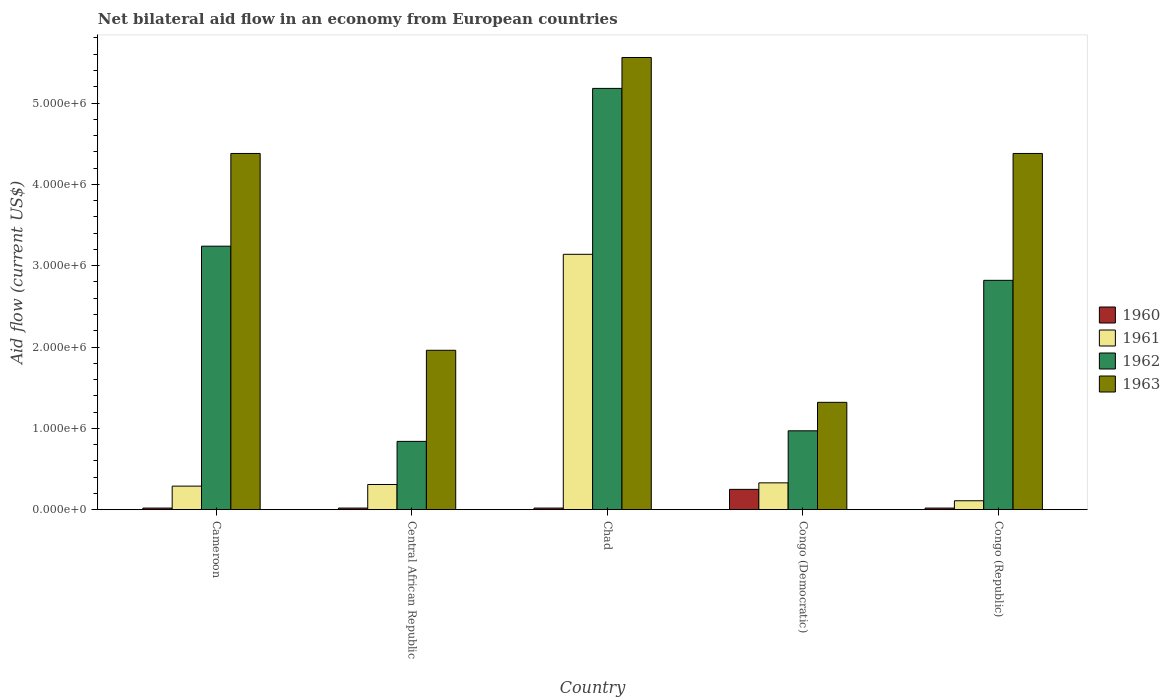How many different coloured bars are there?
Keep it short and to the point. 4. Are the number of bars per tick equal to the number of legend labels?
Your answer should be compact. Yes. Are the number of bars on each tick of the X-axis equal?
Provide a succinct answer. Yes. How many bars are there on the 4th tick from the right?
Ensure brevity in your answer.  4. What is the label of the 2nd group of bars from the left?
Keep it short and to the point. Central African Republic. What is the net bilateral aid flow in 1960 in Central African Republic?
Your response must be concise. 2.00e+04. Across all countries, what is the maximum net bilateral aid flow in 1960?
Provide a succinct answer. 2.50e+05. Across all countries, what is the minimum net bilateral aid flow in 1961?
Ensure brevity in your answer.  1.10e+05. In which country was the net bilateral aid flow in 1962 maximum?
Your response must be concise. Chad. In which country was the net bilateral aid flow in 1963 minimum?
Provide a short and direct response. Congo (Democratic). What is the total net bilateral aid flow in 1961 in the graph?
Give a very brief answer. 4.18e+06. What is the difference between the net bilateral aid flow in 1963 in Congo (Democratic) and that in Congo (Republic)?
Provide a short and direct response. -3.06e+06. What is the difference between the net bilateral aid flow in 1962 in Congo (Republic) and the net bilateral aid flow in 1961 in Congo (Democratic)?
Your answer should be very brief. 2.49e+06. What is the average net bilateral aid flow in 1960 per country?
Make the answer very short. 6.60e+04. What is the difference between the net bilateral aid flow of/in 1963 and net bilateral aid flow of/in 1960 in Chad?
Make the answer very short. 5.54e+06. In how many countries, is the net bilateral aid flow in 1960 greater than 1400000 US$?
Your answer should be very brief. 0. What is the ratio of the net bilateral aid flow in 1963 in Central African Republic to that in Congo (Republic)?
Keep it short and to the point. 0.45. Is the net bilateral aid flow in 1960 in Central African Republic less than that in Congo (Democratic)?
Offer a very short reply. Yes. Is the difference between the net bilateral aid flow in 1963 in Congo (Democratic) and Congo (Republic) greater than the difference between the net bilateral aid flow in 1960 in Congo (Democratic) and Congo (Republic)?
Provide a succinct answer. No. What is the difference between the highest and the second highest net bilateral aid flow in 1963?
Provide a short and direct response. 1.18e+06. In how many countries, is the net bilateral aid flow in 1960 greater than the average net bilateral aid flow in 1960 taken over all countries?
Your answer should be very brief. 1. Is the sum of the net bilateral aid flow in 1960 in Central African Republic and Congo (Democratic) greater than the maximum net bilateral aid flow in 1961 across all countries?
Your response must be concise. No. Is it the case that in every country, the sum of the net bilateral aid flow in 1963 and net bilateral aid flow in 1962 is greater than the sum of net bilateral aid flow in 1961 and net bilateral aid flow in 1960?
Keep it short and to the point. Yes. What does the 4th bar from the right in Central African Republic represents?
Offer a terse response. 1960. How many bars are there?
Provide a succinct answer. 20. How many countries are there in the graph?
Your answer should be compact. 5. What is the difference between two consecutive major ticks on the Y-axis?
Give a very brief answer. 1.00e+06. Are the values on the major ticks of Y-axis written in scientific E-notation?
Make the answer very short. Yes. Does the graph contain grids?
Keep it short and to the point. No. Where does the legend appear in the graph?
Your answer should be compact. Center right. How are the legend labels stacked?
Give a very brief answer. Vertical. What is the title of the graph?
Your answer should be very brief. Net bilateral aid flow in an economy from European countries. What is the Aid flow (current US$) in 1961 in Cameroon?
Your answer should be compact. 2.90e+05. What is the Aid flow (current US$) in 1962 in Cameroon?
Your answer should be very brief. 3.24e+06. What is the Aid flow (current US$) of 1963 in Cameroon?
Provide a short and direct response. 4.38e+06. What is the Aid flow (current US$) of 1962 in Central African Republic?
Provide a short and direct response. 8.40e+05. What is the Aid flow (current US$) in 1963 in Central African Republic?
Make the answer very short. 1.96e+06. What is the Aid flow (current US$) in 1961 in Chad?
Give a very brief answer. 3.14e+06. What is the Aid flow (current US$) in 1962 in Chad?
Provide a succinct answer. 5.18e+06. What is the Aid flow (current US$) in 1963 in Chad?
Offer a very short reply. 5.56e+06. What is the Aid flow (current US$) of 1961 in Congo (Democratic)?
Give a very brief answer. 3.30e+05. What is the Aid flow (current US$) of 1962 in Congo (Democratic)?
Offer a very short reply. 9.70e+05. What is the Aid flow (current US$) of 1963 in Congo (Democratic)?
Give a very brief answer. 1.32e+06. What is the Aid flow (current US$) of 1960 in Congo (Republic)?
Keep it short and to the point. 2.00e+04. What is the Aid flow (current US$) in 1962 in Congo (Republic)?
Give a very brief answer. 2.82e+06. What is the Aid flow (current US$) of 1963 in Congo (Republic)?
Your answer should be compact. 4.38e+06. Across all countries, what is the maximum Aid flow (current US$) in 1960?
Your response must be concise. 2.50e+05. Across all countries, what is the maximum Aid flow (current US$) of 1961?
Ensure brevity in your answer.  3.14e+06. Across all countries, what is the maximum Aid flow (current US$) in 1962?
Your answer should be compact. 5.18e+06. Across all countries, what is the maximum Aid flow (current US$) in 1963?
Offer a very short reply. 5.56e+06. Across all countries, what is the minimum Aid flow (current US$) in 1960?
Offer a very short reply. 2.00e+04. Across all countries, what is the minimum Aid flow (current US$) of 1961?
Provide a short and direct response. 1.10e+05. Across all countries, what is the minimum Aid flow (current US$) of 1962?
Your answer should be very brief. 8.40e+05. Across all countries, what is the minimum Aid flow (current US$) of 1963?
Give a very brief answer. 1.32e+06. What is the total Aid flow (current US$) in 1961 in the graph?
Keep it short and to the point. 4.18e+06. What is the total Aid flow (current US$) of 1962 in the graph?
Make the answer very short. 1.30e+07. What is the total Aid flow (current US$) in 1963 in the graph?
Keep it short and to the point. 1.76e+07. What is the difference between the Aid flow (current US$) in 1962 in Cameroon and that in Central African Republic?
Provide a short and direct response. 2.40e+06. What is the difference between the Aid flow (current US$) of 1963 in Cameroon and that in Central African Republic?
Your answer should be very brief. 2.42e+06. What is the difference between the Aid flow (current US$) in 1961 in Cameroon and that in Chad?
Ensure brevity in your answer.  -2.85e+06. What is the difference between the Aid flow (current US$) in 1962 in Cameroon and that in Chad?
Your answer should be compact. -1.94e+06. What is the difference between the Aid flow (current US$) of 1963 in Cameroon and that in Chad?
Make the answer very short. -1.18e+06. What is the difference between the Aid flow (current US$) of 1961 in Cameroon and that in Congo (Democratic)?
Provide a succinct answer. -4.00e+04. What is the difference between the Aid flow (current US$) of 1962 in Cameroon and that in Congo (Democratic)?
Offer a very short reply. 2.27e+06. What is the difference between the Aid flow (current US$) in 1963 in Cameroon and that in Congo (Democratic)?
Ensure brevity in your answer.  3.06e+06. What is the difference between the Aid flow (current US$) in 1961 in Cameroon and that in Congo (Republic)?
Offer a terse response. 1.80e+05. What is the difference between the Aid flow (current US$) in 1962 in Cameroon and that in Congo (Republic)?
Make the answer very short. 4.20e+05. What is the difference between the Aid flow (current US$) in 1961 in Central African Republic and that in Chad?
Keep it short and to the point. -2.83e+06. What is the difference between the Aid flow (current US$) of 1962 in Central African Republic and that in Chad?
Your answer should be compact. -4.34e+06. What is the difference between the Aid flow (current US$) in 1963 in Central African Republic and that in Chad?
Your answer should be very brief. -3.60e+06. What is the difference between the Aid flow (current US$) in 1961 in Central African Republic and that in Congo (Democratic)?
Offer a very short reply. -2.00e+04. What is the difference between the Aid flow (current US$) in 1963 in Central African Republic and that in Congo (Democratic)?
Give a very brief answer. 6.40e+05. What is the difference between the Aid flow (current US$) of 1961 in Central African Republic and that in Congo (Republic)?
Provide a succinct answer. 2.00e+05. What is the difference between the Aid flow (current US$) in 1962 in Central African Republic and that in Congo (Republic)?
Offer a terse response. -1.98e+06. What is the difference between the Aid flow (current US$) in 1963 in Central African Republic and that in Congo (Republic)?
Offer a terse response. -2.42e+06. What is the difference between the Aid flow (current US$) in 1960 in Chad and that in Congo (Democratic)?
Your response must be concise. -2.30e+05. What is the difference between the Aid flow (current US$) of 1961 in Chad and that in Congo (Democratic)?
Make the answer very short. 2.81e+06. What is the difference between the Aid flow (current US$) of 1962 in Chad and that in Congo (Democratic)?
Your answer should be compact. 4.21e+06. What is the difference between the Aid flow (current US$) of 1963 in Chad and that in Congo (Democratic)?
Offer a terse response. 4.24e+06. What is the difference between the Aid flow (current US$) of 1960 in Chad and that in Congo (Republic)?
Keep it short and to the point. 0. What is the difference between the Aid flow (current US$) in 1961 in Chad and that in Congo (Republic)?
Your answer should be very brief. 3.03e+06. What is the difference between the Aid flow (current US$) of 1962 in Chad and that in Congo (Republic)?
Your answer should be very brief. 2.36e+06. What is the difference between the Aid flow (current US$) in 1963 in Chad and that in Congo (Republic)?
Provide a short and direct response. 1.18e+06. What is the difference between the Aid flow (current US$) of 1962 in Congo (Democratic) and that in Congo (Republic)?
Your response must be concise. -1.85e+06. What is the difference between the Aid flow (current US$) in 1963 in Congo (Democratic) and that in Congo (Republic)?
Provide a succinct answer. -3.06e+06. What is the difference between the Aid flow (current US$) of 1960 in Cameroon and the Aid flow (current US$) of 1962 in Central African Republic?
Your response must be concise. -8.20e+05. What is the difference between the Aid flow (current US$) in 1960 in Cameroon and the Aid flow (current US$) in 1963 in Central African Republic?
Provide a short and direct response. -1.94e+06. What is the difference between the Aid flow (current US$) in 1961 in Cameroon and the Aid flow (current US$) in 1962 in Central African Republic?
Offer a very short reply. -5.50e+05. What is the difference between the Aid flow (current US$) of 1961 in Cameroon and the Aid flow (current US$) of 1963 in Central African Republic?
Provide a succinct answer. -1.67e+06. What is the difference between the Aid flow (current US$) in 1962 in Cameroon and the Aid flow (current US$) in 1963 in Central African Republic?
Give a very brief answer. 1.28e+06. What is the difference between the Aid flow (current US$) of 1960 in Cameroon and the Aid flow (current US$) of 1961 in Chad?
Offer a very short reply. -3.12e+06. What is the difference between the Aid flow (current US$) of 1960 in Cameroon and the Aid flow (current US$) of 1962 in Chad?
Offer a terse response. -5.16e+06. What is the difference between the Aid flow (current US$) of 1960 in Cameroon and the Aid flow (current US$) of 1963 in Chad?
Provide a succinct answer. -5.54e+06. What is the difference between the Aid flow (current US$) in 1961 in Cameroon and the Aid flow (current US$) in 1962 in Chad?
Offer a very short reply. -4.89e+06. What is the difference between the Aid flow (current US$) of 1961 in Cameroon and the Aid flow (current US$) of 1963 in Chad?
Provide a short and direct response. -5.27e+06. What is the difference between the Aid flow (current US$) of 1962 in Cameroon and the Aid flow (current US$) of 1963 in Chad?
Provide a succinct answer. -2.32e+06. What is the difference between the Aid flow (current US$) in 1960 in Cameroon and the Aid flow (current US$) in 1961 in Congo (Democratic)?
Make the answer very short. -3.10e+05. What is the difference between the Aid flow (current US$) of 1960 in Cameroon and the Aid flow (current US$) of 1962 in Congo (Democratic)?
Provide a succinct answer. -9.50e+05. What is the difference between the Aid flow (current US$) in 1960 in Cameroon and the Aid flow (current US$) in 1963 in Congo (Democratic)?
Ensure brevity in your answer.  -1.30e+06. What is the difference between the Aid flow (current US$) in 1961 in Cameroon and the Aid flow (current US$) in 1962 in Congo (Democratic)?
Provide a short and direct response. -6.80e+05. What is the difference between the Aid flow (current US$) of 1961 in Cameroon and the Aid flow (current US$) of 1963 in Congo (Democratic)?
Provide a short and direct response. -1.03e+06. What is the difference between the Aid flow (current US$) of 1962 in Cameroon and the Aid flow (current US$) of 1963 in Congo (Democratic)?
Provide a succinct answer. 1.92e+06. What is the difference between the Aid flow (current US$) of 1960 in Cameroon and the Aid flow (current US$) of 1962 in Congo (Republic)?
Your response must be concise. -2.80e+06. What is the difference between the Aid flow (current US$) in 1960 in Cameroon and the Aid flow (current US$) in 1963 in Congo (Republic)?
Offer a terse response. -4.36e+06. What is the difference between the Aid flow (current US$) of 1961 in Cameroon and the Aid flow (current US$) of 1962 in Congo (Republic)?
Offer a terse response. -2.53e+06. What is the difference between the Aid flow (current US$) in 1961 in Cameroon and the Aid flow (current US$) in 1963 in Congo (Republic)?
Your answer should be compact. -4.09e+06. What is the difference between the Aid flow (current US$) in 1962 in Cameroon and the Aid flow (current US$) in 1963 in Congo (Republic)?
Offer a very short reply. -1.14e+06. What is the difference between the Aid flow (current US$) in 1960 in Central African Republic and the Aid flow (current US$) in 1961 in Chad?
Make the answer very short. -3.12e+06. What is the difference between the Aid flow (current US$) of 1960 in Central African Republic and the Aid flow (current US$) of 1962 in Chad?
Your response must be concise. -5.16e+06. What is the difference between the Aid flow (current US$) in 1960 in Central African Republic and the Aid flow (current US$) in 1963 in Chad?
Make the answer very short. -5.54e+06. What is the difference between the Aid flow (current US$) of 1961 in Central African Republic and the Aid flow (current US$) of 1962 in Chad?
Ensure brevity in your answer.  -4.87e+06. What is the difference between the Aid flow (current US$) in 1961 in Central African Republic and the Aid flow (current US$) in 1963 in Chad?
Your answer should be very brief. -5.25e+06. What is the difference between the Aid flow (current US$) of 1962 in Central African Republic and the Aid flow (current US$) of 1963 in Chad?
Give a very brief answer. -4.72e+06. What is the difference between the Aid flow (current US$) in 1960 in Central African Republic and the Aid flow (current US$) in 1961 in Congo (Democratic)?
Make the answer very short. -3.10e+05. What is the difference between the Aid flow (current US$) of 1960 in Central African Republic and the Aid flow (current US$) of 1962 in Congo (Democratic)?
Keep it short and to the point. -9.50e+05. What is the difference between the Aid flow (current US$) of 1960 in Central African Republic and the Aid flow (current US$) of 1963 in Congo (Democratic)?
Your answer should be very brief. -1.30e+06. What is the difference between the Aid flow (current US$) of 1961 in Central African Republic and the Aid flow (current US$) of 1962 in Congo (Democratic)?
Ensure brevity in your answer.  -6.60e+05. What is the difference between the Aid flow (current US$) in 1961 in Central African Republic and the Aid flow (current US$) in 1963 in Congo (Democratic)?
Provide a short and direct response. -1.01e+06. What is the difference between the Aid flow (current US$) of 1962 in Central African Republic and the Aid flow (current US$) of 1963 in Congo (Democratic)?
Offer a very short reply. -4.80e+05. What is the difference between the Aid flow (current US$) in 1960 in Central African Republic and the Aid flow (current US$) in 1961 in Congo (Republic)?
Your answer should be compact. -9.00e+04. What is the difference between the Aid flow (current US$) in 1960 in Central African Republic and the Aid flow (current US$) in 1962 in Congo (Republic)?
Offer a terse response. -2.80e+06. What is the difference between the Aid flow (current US$) in 1960 in Central African Republic and the Aid flow (current US$) in 1963 in Congo (Republic)?
Provide a short and direct response. -4.36e+06. What is the difference between the Aid flow (current US$) of 1961 in Central African Republic and the Aid flow (current US$) of 1962 in Congo (Republic)?
Ensure brevity in your answer.  -2.51e+06. What is the difference between the Aid flow (current US$) in 1961 in Central African Republic and the Aid flow (current US$) in 1963 in Congo (Republic)?
Make the answer very short. -4.07e+06. What is the difference between the Aid flow (current US$) in 1962 in Central African Republic and the Aid flow (current US$) in 1963 in Congo (Republic)?
Ensure brevity in your answer.  -3.54e+06. What is the difference between the Aid flow (current US$) in 1960 in Chad and the Aid flow (current US$) in 1961 in Congo (Democratic)?
Ensure brevity in your answer.  -3.10e+05. What is the difference between the Aid flow (current US$) in 1960 in Chad and the Aid flow (current US$) in 1962 in Congo (Democratic)?
Offer a terse response. -9.50e+05. What is the difference between the Aid flow (current US$) of 1960 in Chad and the Aid flow (current US$) of 1963 in Congo (Democratic)?
Provide a succinct answer. -1.30e+06. What is the difference between the Aid flow (current US$) in 1961 in Chad and the Aid flow (current US$) in 1962 in Congo (Democratic)?
Offer a terse response. 2.17e+06. What is the difference between the Aid flow (current US$) of 1961 in Chad and the Aid flow (current US$) of 1963 in Congo (Democratic)?
Provide a short and direct response. 1.82e+06. What is the difference between the Aid flow (current US$) of 1962 in Chad and the Aid flow (current US$) of 1963 in Congo (Democratic)?
Give a very brief answer. 3.86e+06. What is the difference between the Aid flow (current US$) of 1960 in Chad and the Aid flow (current US$) of 1961 in Congo (Republic)?
Your response must be concise. -9.00e+04. What is the difference between the Aid flow (current US$) in 1960 in Chad and the Aid flow (current US$) in 1962 in Congo (Republic)?
Make the answer very short. -2.80e+06. What is the difference between the Aid flow (current US$) of 1960 in Chad and the Aid flow (current US$) of 1963 in Congo (Republic)?
Offer a terse response. -4.36e+06. What is the difference between the Aid flow (current US$) in 1961 in Chad and the Aid flow (current US$) in 1962 in Congo (Republic)?
Your answer should be very brief. 3.20e+05. What is the difference between the Aid flow (current US$) of 1961 in Chad and the Aid flow (current US$) of 1963 in Congo (Republic)?
Provide a short and direct response. -1.24e+06. What is the difference between the Aid flow (current US$) in 1962 in Chad and the Aid flow (current US$) in 1963 in Congo (Republic)?
Make the answer very short. 8.00e+05. What is the difference between the Aid flow (current US$) in 1960 in Congo (Democratic) and the Aid flow (current US$) in 1962 in Congo (Republic)?
Keep it short and to the point. -2.57e+06. What is the difference between the Aid flow (current US$) of 1960 in Congo (Democratic) and the Aid flow (current US$) of 1963 in Congo (Republic)?
Offer a very short reply. -4.13e+06. What is the difference between the Aid flow (current US$) of 1961 in Congo (Democratic) and the Aid flow (current US$) of 1962 in Congo (Republic)?
Offer a terse response. -2.49e+06. What is the difference between the Aid flow (current US$) of 1961 in Congo (Democratic) and the Aid flow (current US$) of 1963 in Congo (Republic)?
Ensure brevity in your answer.  -4.05e+06. What is the difference between the Aid flow (current US$) of 1962 in Congo (Democratic) and the Aid flow (current US$) of 1963 in Congo (Republic)?
Provide a short and direct response. -3.41e+06. What is the average Aid flow (current US$) in 1960 per country?
Keep it short and to the point. 6.60e+04. What is the average Aid flow (current US$) of 1961 per country?
Keep it short and to the point. 8.36e+05. What is the average Aid flow (current US$) in 1962 per country?
Ensure brevity in your answer.  2.61e+06. What is the average Aid flow (current US$) of 1963 per country?
Offer a very short reply. 3.52e+06. What is the difference between the Aid flow (current US$) in 1960 and Aid flow (current US$) in 1962 in Cameroon?
Your answer should be compact. -3.22e+06. What is the difference between the Aid flow (current US$) in 1960 and Aid flow (current US$) in 1963 in Cameroon?
Ensure brevity in your answer.  -4.36e+06. What is the difference between the Aid flow (current US$) in 1961 and Aid flow (current US$) in 1962 in Cameroon?
Provide a short and direct response. -2.95e+06. What is the difference between the Aid flow (current US$) in 1961 and Aid flow (current US$) in 1963 in Cameroon?
Your answer should be very brief. -4.09e+06. What is the difference between the Aid flow (current US$) in 1962 and Aid flow (current US$) in 1963 in Cameroon?
Make the answer very short. -1.14e+06. What is the difference between the Aid flow (current US$) of 1960 and Aid flow (current US$) of 1962 in Central African Republic?
Provide a short and direct response. -8.20e+05. What is the difference between the Aid flow (current US$) of 1960 and Aid flow (current US$) of 1963 in Central African Republic?
Offer a very short reply. -1.94e+06. What is the difference between the Aid flow (current US$) in 1961 and Aid flow (current US$) in 1962 in Central African Republic?
Your answer should be very brief. -5.30e+05. What is the difference between the Aid flow (current US$) of 1961 and Aid flow (current US$) of 1963 in Central African Republic?
Your answer should be compact. -1.65e+06. What is the difference between the Aid flow (current US$) in 1962 and Aid flow (current US$) in 1963 in Central African Republic?
Give a very brief answer. -1.12e+06. What is the difference between the Aid flow (current US$) in 1960 and Aid flow (current US$) in 1961 in Chad?
Your answer should be compact. -3.12e+06. What is the difference between the Aid flow (current US$) of 1960 and Aid flow (current US$) of 1962 in Chad?
Offer a terse response. -5.16e+06. What is the difference between the Aid flow (current US$) in 1960 and Aid flow (current US$) in 1963 in Chad?
Your response must be concise. -5.54e+06. What is the difference between the Aid flow (current US$) in 1961 and Aid flow (current US$) in 1962 in Chad?
Make the answer very short. -2.04e+06. What is the difference between the Aid flow (current US$) in 1961 and Aid flow (current US$) in 1963 in Chad?
Your response must be concise. -2.42e+06. What is the difference between the Aid flow (current US$) of 1962 and Aid flow (current US$) of 1963 in Chad?
Provide a succinct answer. -3.80e+05. What is the difference between the Aid flow (current US$) in 1960 and Aid flow (current US$) in 1962 in Congo (Democratic)?
Offer a terse response. -7.20e+05. What is the difference between the Aid flow (current US$) in 1960 and Aid flow (current US$) in 1963 in Congo (Democratic)?
Give a very brief answer. -1.07e+06. What is the difference between the Aid flow (current US$) of 1961 and Aid flow (current US$) of 1962 in Congo (Democratic)?
Keep it short and to the point. -6.40e+05. What is the difference between the Aid flow (current US$) of 1961 and Aid flow (current US$) of 1963 in Congo (Democratic)?
Offer a terse response. -9.90e+05. What is the difference between the Aid flow (current US$) of 1962 and Aid flow (current US$) of 1963 in Congo (Democratic)?
Your answer should be very brief. -3.50e+05. What is the difference between the Aid flow (current US$) in 1960 and Aid flow (current US$) in 1962 in Congo (Republic)?
Offer a terse response. -2.80e+06. What is the difference between the Aid flow (current US$) in 1960 and Aid flow (current US$) in 1963 in Congo (Republic)?
Provide a short and direct response. -4.36e+06. What is the difference between the Aid flow (current US$) in 1961 and Aid flow (current US$) in 1962 in Congo (Republic)?
Offer a very short reply. -2.71e+06. What is the difference between the Aid flow (current US$) in 1961 and Aid flow (current US$) in 1963 in Congo (Republic)?
Your response must be concise. -4.27e+06. What is the difference between the Aid flow (current US$) of 1962 and Aid flow (current US$) of 1963 in Congo (Republic)?
Ensure brevity in your answer.  -1.56e+06. What is the ratio of the Aid flow (current US$) in 1961 in Cameroon to that in Central African Republic?
Provide a succinct answer. 0.94. What is the ratio of the Aid flow (current US$) in 1962 in Cameroon to that in Central African Republic?
Your response must be concise. 3.86. What is the ratio of the Aid flow (current US$) in 1963 in Cameroon to that in Central African Republic?
Offer a very short reply. 2.23. What is the ratio of the Aid flow (current US$) in 1960 in Cameroon to that in Chad?
Provide a short and direct response. 1. What is the ratio of the Aid flow (current US$) in 1961 in Cameroon to that in Chad?
Your response must be concise. 0.09. What is the ratio of the Aid flow (current US$) in 1962 in Cameroon to that in Chad?
Ensure brevity in your answer.  0.63. What is the ratio of the Aid flow (current US$) in 1963 in Cameroon to that in Chad?
Your answer should be very brief. 0.79. What is the ratio of the Aid flow (current US$) in 1961 in Cameroon to that in Congo (Democratic)?
Keep it short and to the point. 0.88. What is the ratio of the Aid flow (current US$) of 1962 in Cameroon to that in Congo (Democratic)?
Keep it short and to the point. 3.34. What is the ratio of the Aid flow (current US$) of 1963 in Cameroon to that in Congo (Democratic)?
Give a very brief answer. 3.32. What is the ratio of the Aid flow (current US$) of 1961 in Cameroon to that in Congo (Republic)?
Ensure brevity in your answer.  2.64. What is the ratio of the Aid flow (current US$) in 1962 in Cameroon to that in Congo (Republic)?
Your answer should be very brief. 1.15. What is the ratio of the Aid flow (current US$) in 1963 in Cameroon to that in Congo (Republic)?
Provide a succinct answer. 1. What is the ratio of the Aid flow (current US$) in 1961 in Central African Republic to that in Chad?
Provide a short and direct response. 0.1. What is the ratio of the Aid flow (current US$) of 1962 in Central African Republic to that in Chad?
Ensure brevity in your answer.  0.16. What is the ratio of the Aid flow (current US$) in 1963 in Central African Republic to that in Chad?
Give a very brief answer. 0.35. What is the ratio of the Aid flow (current US$) in 1960 in Central African Republic to that in Congo (Democratic)?
Your answer should be compact. 0.08. What is the ratio of the Aid flow (current US$) in 1961 in Central African Republic to that in Congo (Democratic)?
Your answer should be compact. 0.94. What is the ratio of the Aid flow (current US$) in 1962 in Central African Republic to that in Congo (Democratic)?
Your answer should be very brief. 0.87. What is the ratio of the Aid flow (current US$) in 1963 in Central African Republic to that in Congo (Democratic)?
Offer a very short reply. 1.48. What is the ratio of the Aid flow (current US$) of 1960 in Central African Republic to that in Congo (Republic)?
Provide a short and direct response. 1. What is the ratio of the Aid flow (current US$) in 1961 in Central African Republic to that in Congo (Republic)?
Your answer should be very brief. 2.82. What is the ratio of the Aid flow (current US$) in 1962 in Central African Republic to that in Congo (Republic)?
Provide a succinct answer. 0.3. What is the ratio of the Aid flow (current US$) in 1963 in Central African Republic to that in Congo (Republic)?
Your answer should be compact. 0.45. What is the ratio of the Aid flow (current US$) in 1961 in Chad to that in Congo (Democratic)?
Offer a terse response. 9.52. What is the ratio of the Aid flow (current US$) in 1962 in Chad to that in Congo (Democratic)?
Offer a very short reply. 5.34. What is the ratio of the Aid flow (current US$) of 1963 in Chad to that in Congo (Democratic)?
Give a very brief answer. 4.21. What is the ratio of the Aid flow (current US$) in 1960 in Chad to that in Congo (Republic)?
Make the answer very short. 1. What is the ratio of the Aid flow (current US$) in 1961 in Chad to that in Congo (Republic)?
Make the answer very short. 28.55. What is the ratio of the Aid flow (current US$) in 1962 in Chad to that in Congo (Republic)?
Give a very brief answer. 1.84. What is the ratio of the Aid flow (current US$) of 1963 in Chad to that in Congo (Republic)?
Offer a terse response. 1.27. What is the ratio of the Aid flow (current US$) in 1960 in Congo (Democratic) to that in Congo (Republic)?
Make the answer very short. 12.5. What is the ratio of the Aid flow (current US$) of 1962 in Congo (Democratic) to that in Congo (Republic)?
Your answer should be very brief. 0.34. What is the ratio of the Aid flow (current US$) of 1963 in Congo (Democratic) to that in Congo (Republic)?
Provide a succinct answer. 0.3. What is the difference between the highest and the second highest Aid flow (current US$) of 1961?
Ensure brevity in your answer.  2.81e+06. What is the difference between the highest and the second highest Aid flow (current US$) in 1962?
Your answer should be compact. 1.94e+06. What is the difference between the highest and the second highest Aid flow (current US$) of 1963?
Ensure brevity in your answer.  1.18e+06. What is the difference between the highest and the lowest Aid flow (current US$) of 1960?
Your response must be concise. 2.30e+05. What is the difference between the highest and the lowest Aid flow (current US$) in 1961?
Provide a succinct answer. 3.03e+06. What is the difference between the highest and the lowest Aid flow (current US$) of 1962?
Provide a succinct answer. 4.34e+06. What is the difference between the highest and the lowest Aid flow (current US$) of 1963?
Offer a very short reply. 4.24e+06. 